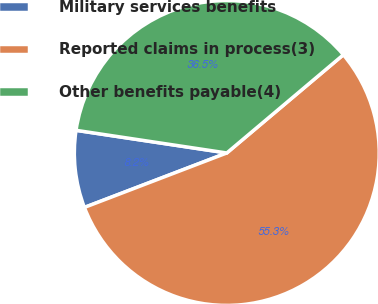<chart> <loc_0><loc_0><loc_500><loc_500><pie_chart><fcel>Military services benefits<fcel>Reported claims in process(3)<fcel>Other benefits payable(4)<nl><fcel>8.19%<fcel>55.33%<fcel>36.48%<nl></chart> 